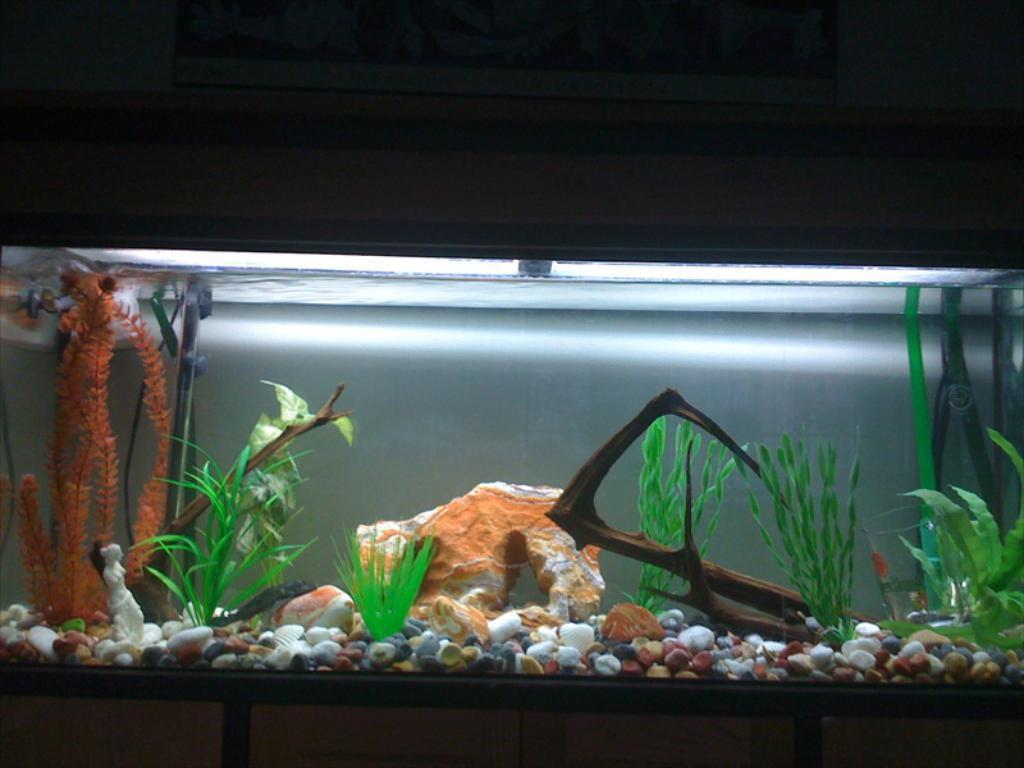Describe this image in one or two sentences. There is an aquarium, in which, there are stones, plants and other objects. The background is dark in color. 